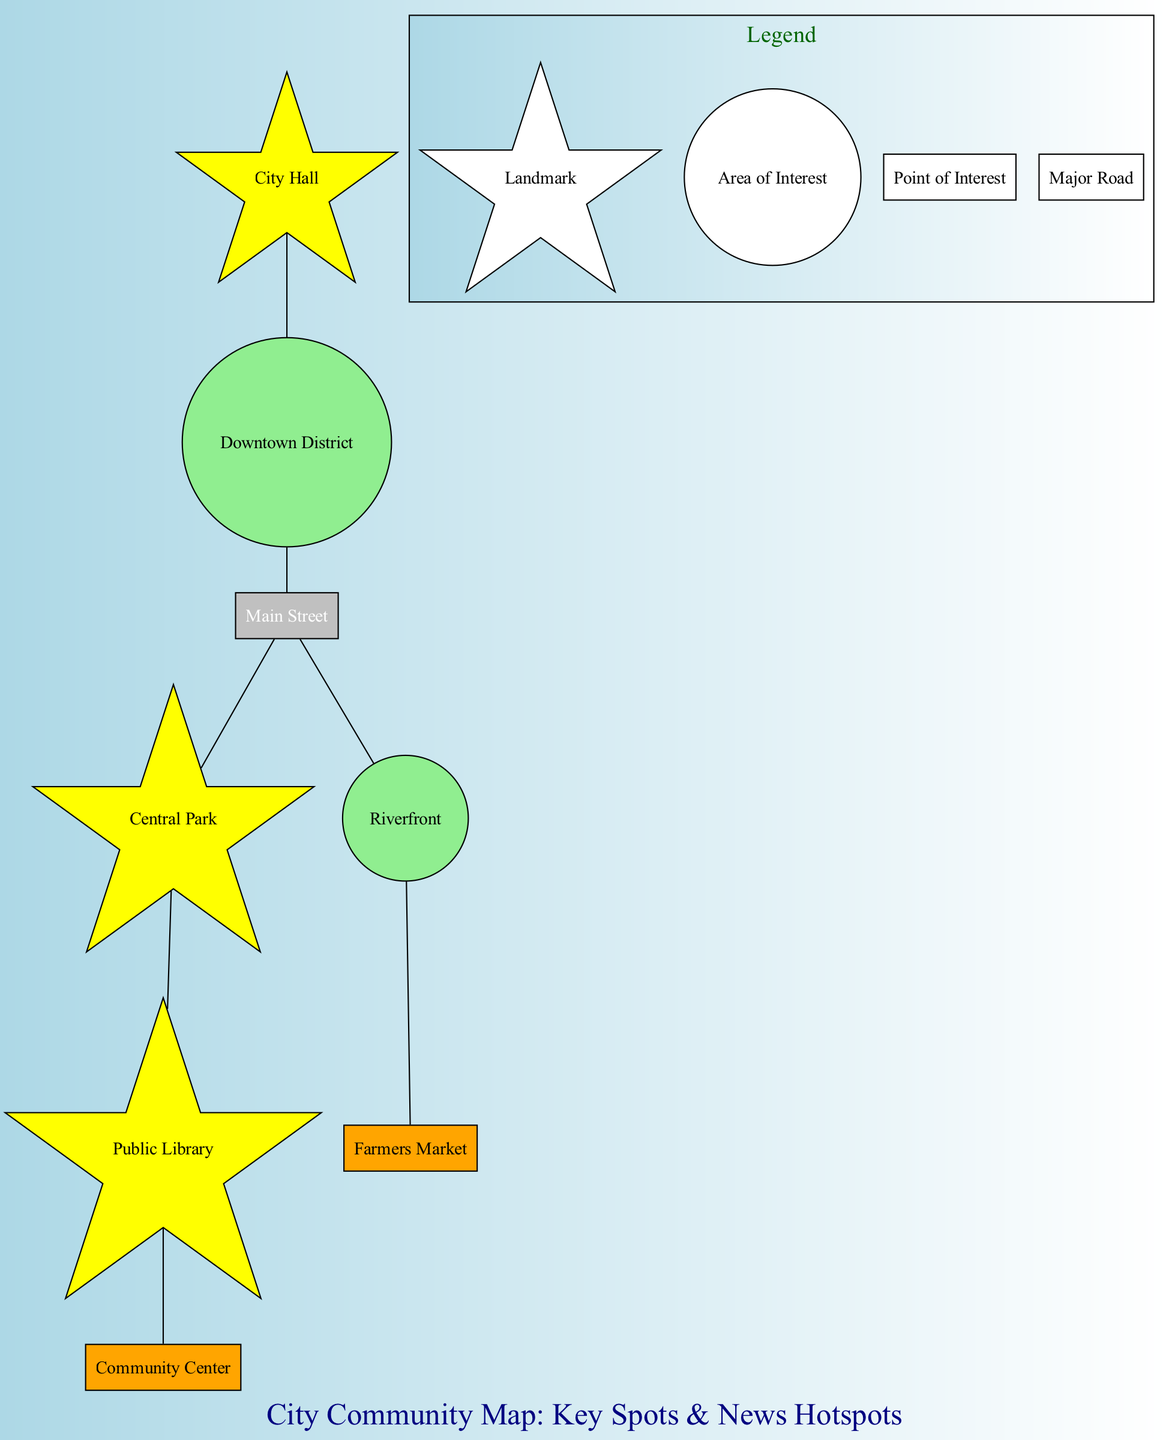What landmark is a local government hub? The diagram identifies "City Hall" as a landmark and describes it as a local government hub, indicating its significance in the community.
Answer: City Hall How many areas of interest are highlighted in the diagram? The diagram lists two areas of interest: "Downtown District" and "Riverfront," thus totaling two specific areas highlighted on the map.
Answer: 2 What type of gathering spot is the Farmers Market? According to the diagram, the "Farmers Market" is categorized as a point of interest, indicating its status as a specific location for community engagement with local produce.
Answer: Point of Interest Which two landmarks are directly connected by Main Street? The diagram shows "Central Park" and "Downtown District" as landmarks both connected through "Main Street," showcasing their proximity in the community layout.
Answer: Central Park, Downtown District What does the symbol shaped like a circle represent in the legend? The legend specifies that the circle symbol represents "Area of Interest," which helps to categorize that shape within the context of the community map.
Answer: Area of Interest What can be found at the Public Library? The diagram states that the "Public Library" hosts community meetings and educational programs, making it an important gathering place for local residents.
Answer: Community meetings and educational programs What is the main focus of news coverage in the Downtown District? The diagram indicates that "Downtown District" is the area focused on business news and economic developments, illustrating its relevance in local news topics.
Answer: Business news and economic developments Which point of interest is associated with social services? The diagram identifies "Community Center" as the point of interest linked to social services and youth programs, highlighting its role in community support.
Answer: Community Center What type of roadway connects the key areas in the city? The diagram denotes "Main Street" as a major road connecting essential areas, indicating its importance for traffic flow and accessibility in the community.
Answer: Major Road 